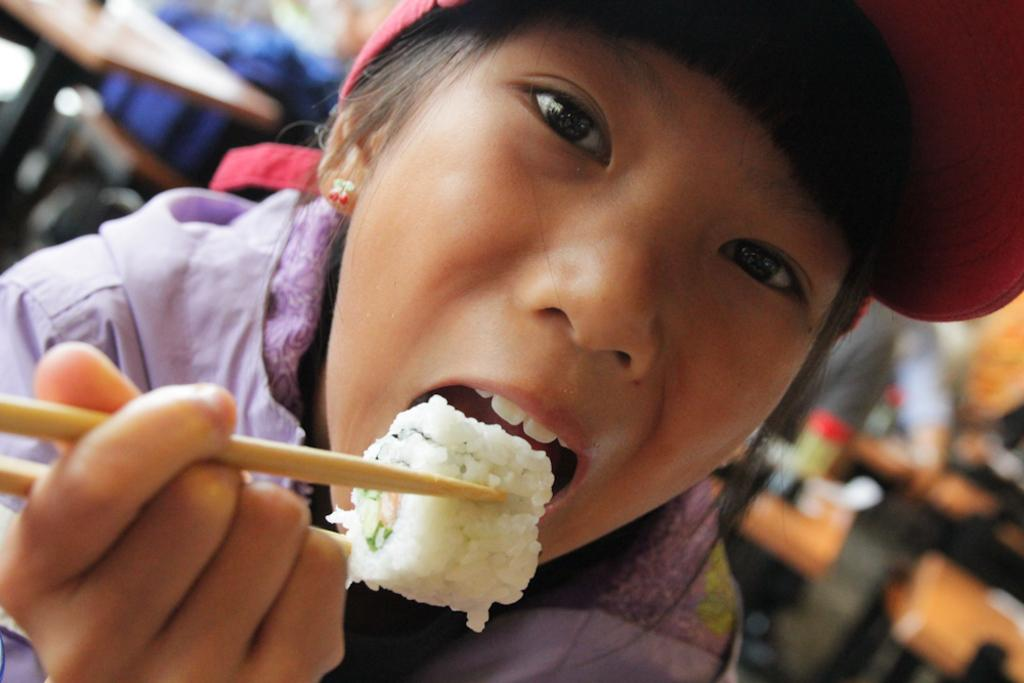Who is the main subject in the image? There is a girl in the image. What is the girl wearing on her head? The girl is wearing a cap. What is the girl doing in the image? The girl is eating food. How is the girl eating the food? The girl is using chopsticks to eat the food. What is the girl's reaction to the sky in the image? There is no mention of the sky in the image, so it is impossible to determine the girl's reaction to it. 